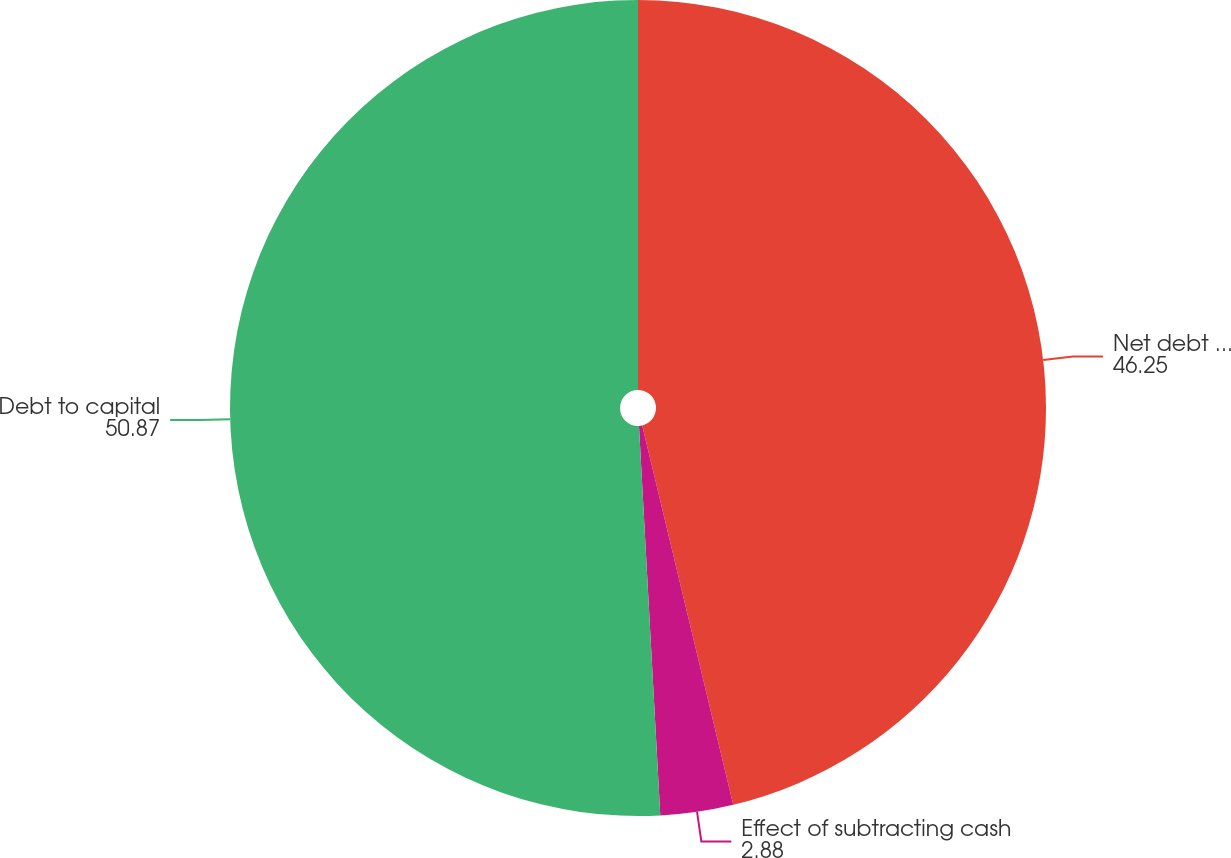Convert chart. <chart><loc_0><loc_0><loc_500><loc_500><pie_chart><fcel>Net debt to net capital<fcel>Effect of subtracting cash<fcel>Debt to capital<nl><fcel>46.25%<fcel>2.88%<fcel>50.87%<nl></chart> 